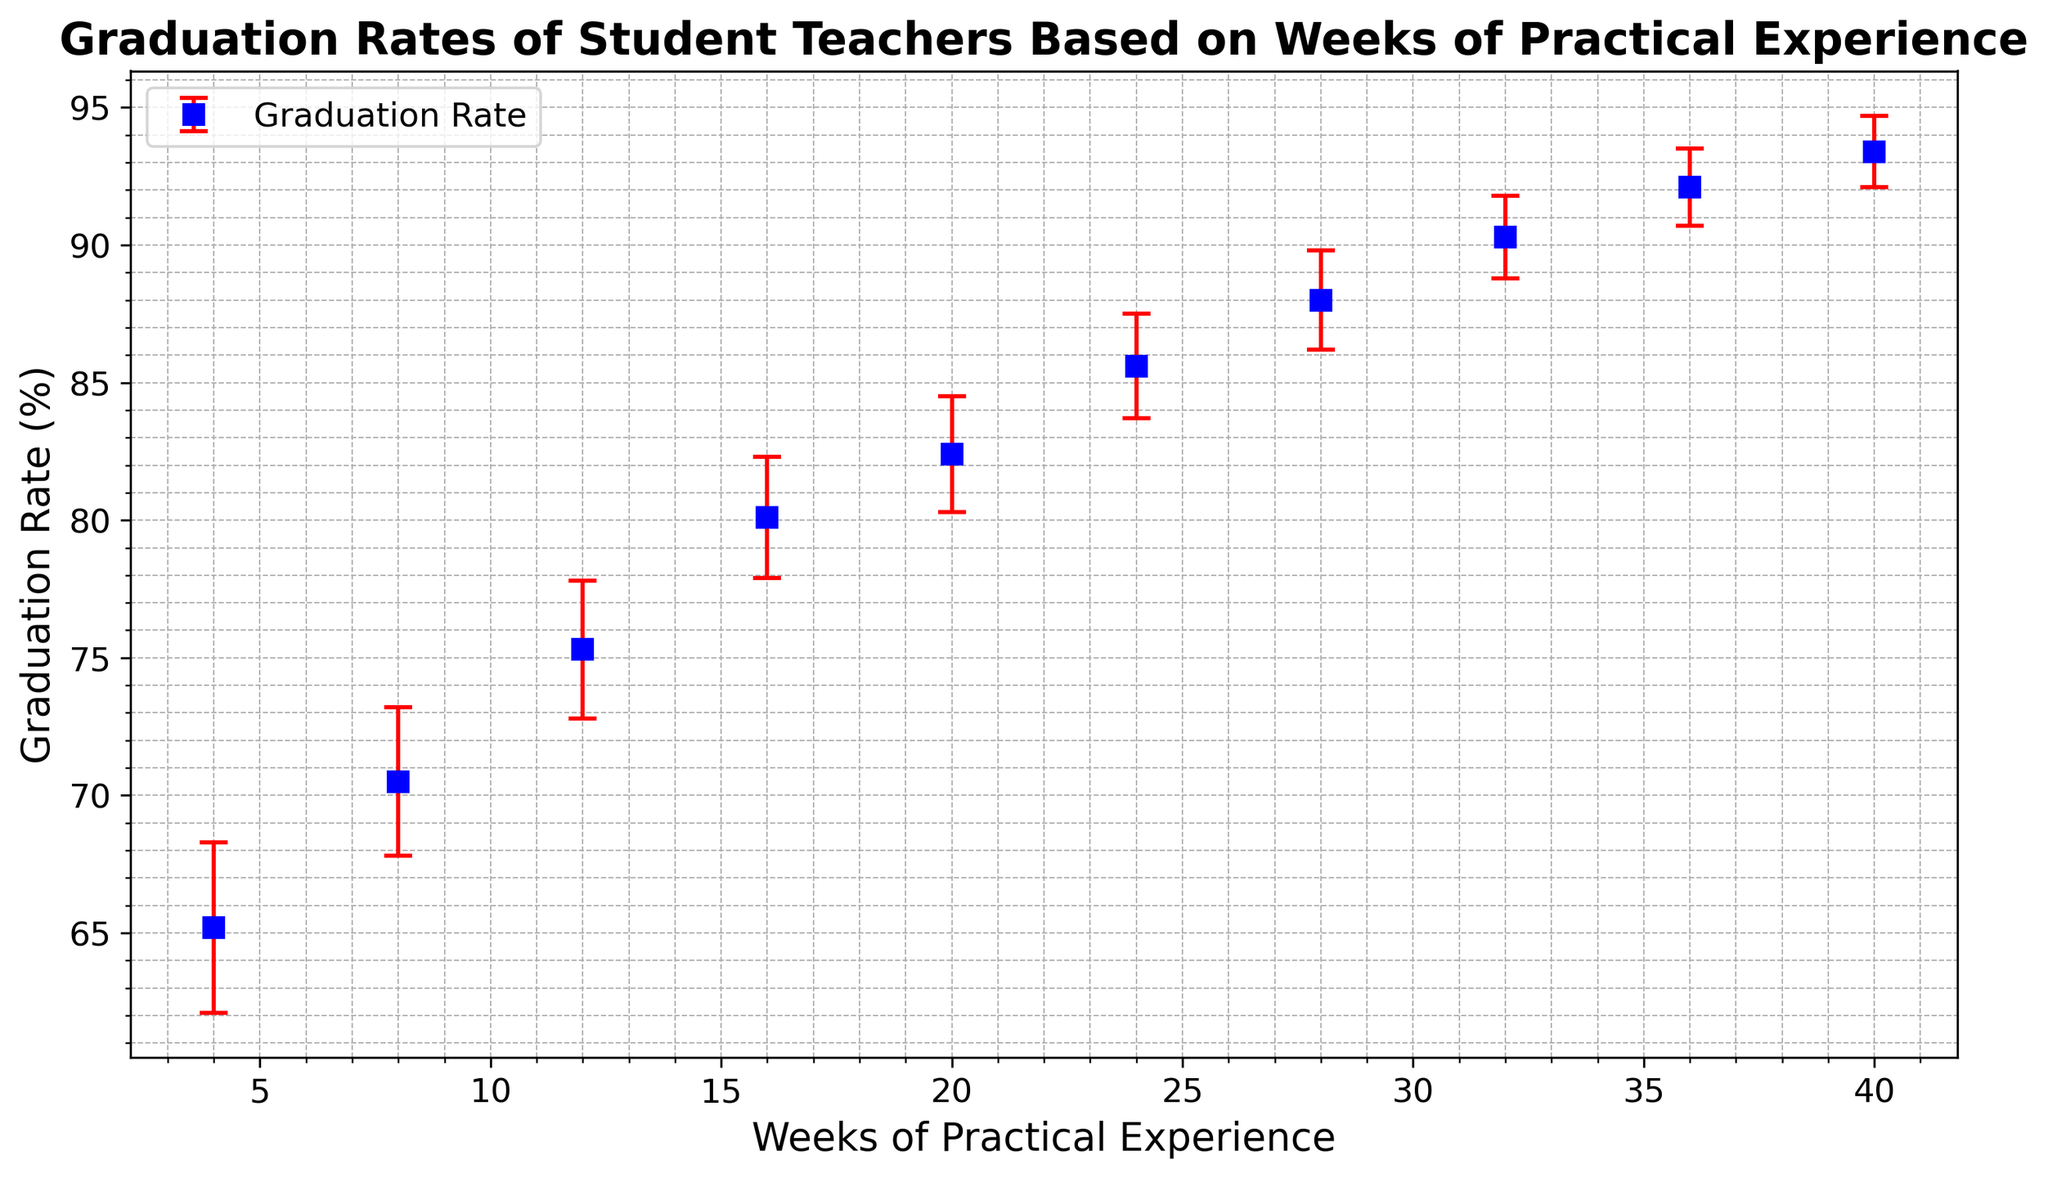What is the Graduation Rate (%) at 24 weeks of practical experience? The point for 24 weeks on the graph indicates the graduation rate. It is shown at approximately 85.6%.
Answer: 85.6% Between which two weeks is the largest increase in Graduation Rate (%) observed? By comparing the differences in graduation rates between consecutive weeks, the largest increase occurs between 16 weeks (80.1%) and 20 weeks (82.4%). The difference is 82.4% - 80.1% = 2.3%.
Answer: Between 16 and 20 weeks What is the average Graduation Rate (%) over 20 to 32 weeks? Sum the graduation rates at 20, 24, 28, and 32 weeks, then divide by the number of these values: (82.4 + 85.6 + 88.0 + 90.3) / 4 = 346.3 / 4 = 86.575.
Answer: 86.575% Which weeks have the smallest and largest error bars? The smallest error bar is at 40 weeks (1.3%), and the largest error bar is at 4 weeks (3.1%) based on the length of the error bars shown in red.
Answer: Smallest: 40 weeks, Largest: 4 weeks Is the Graduation Rate (%) at 16 weeks higher or lower than at 12 weeks? By comparing the graph, the rate at 16 weeks (80.1%) is higher than at 12 weeks (75.3%).
Answer: Higher What is the total increase in Graduation Rate (%) from 4 weeks to 36 weeks? The graduation rate at 4 weeks is 65.2% and at 36 weeks it is 92.1%. The total increase is 92.1% - 65.2% = 26.9%.
Answer: 26.9% What is the error bar length for the Graduation Rate (%) at 8 weeks? The standard error at 8 weeks is 2.7% as indicated by the length of the red error bar in the graph.
Answer: 2.7% How many weeks of practical experience are needed to achieve a Graduation Rate (%) of at least 85%? Based on the graph, a graduation rate of at least 85% is first achieved at 24 weeks.
Answer: 24 weeks Which point on the graph is marked by a blue square with the highest Graduation Rate (%)? The highest graduation rate depicted in the figure corresponds to 40 weeks, marked by the blue square showing 93.4%.
Answer: 40 weeks For how many weeks (in total) do the Graduation Rates (%) fall within the range of 80%-90%? Graduation rates between 80% and 90% are observed at 16, 20, 24, 28, and 32 weeks. This totals to 5 weeks.
Answer: 5 weeks 